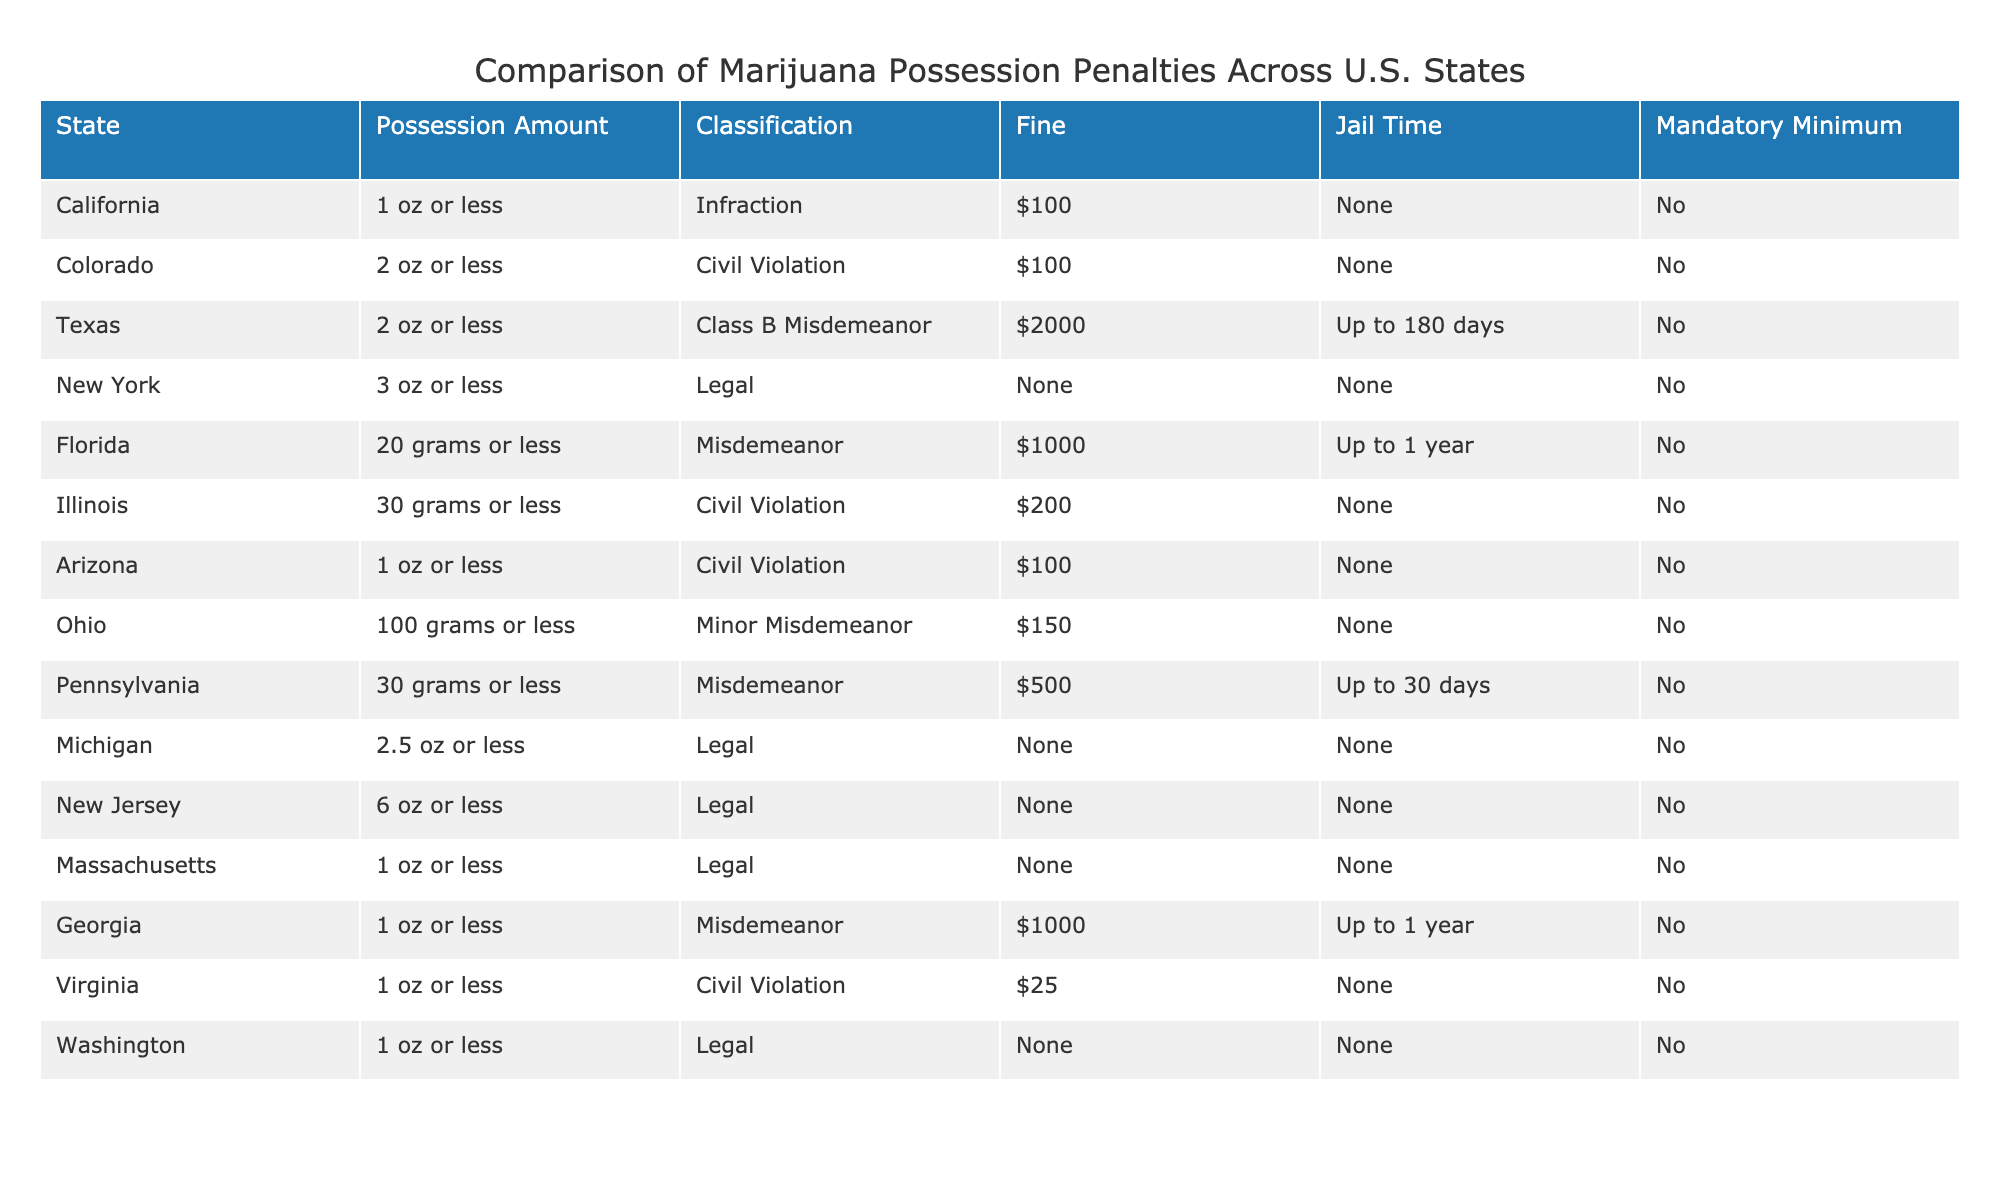What is the possession amount limit in California? According to the table, California allows possession of up to 1 ounce of marijuana or less.
Answer: 1 oz or less Which state has the highest fine for marijuana possession? The table shows that Texas imposes a fine of $2000 for possession of 2 ounces or less, which is the highest fine listed.
Answer: Texas Is marijuana possession legalized in New York? The table indicates that marijuana possession is legal in New York for up to 3 ounces.
Answer: Yes How many states classify marijuana possession as a civil violation? From the table, California, Colorado, Illinois, Arizona, and Virginia classify marijuana possession as a civil violation, totaling 5 states.
Answer: 5 states What is the jail time for possessing 30 grams of marijuana in Pennsylvania? The table states that possession of 30 grams in Pennsylvania is classified as a misdemeanor with a jail time of up to 30 days.
Answer: Up to 30 days Are there any states with a mandatory minimum sentence for marijuana possession? The table shows that no states have a mandatory minimum sentence listed for marijuana possession.
Answer: No Which two states have the same possession amount limit but differ in classification and fines? Florida (20 grams or less, Misdemeanor, $1000) and Ohio (100 grams or less, Minor Misdemeanor, $150) both have different classifications and fines, despite their specified amounts.
Answer: Florida and Ohio If a person is caught with 2 ounces in Colorado, what would be the potential penalties? In Colorado, possessing 2 ounces or less is classified as a civil violation with a fine of $100 and no jail time.
Answer: $100 fine, no jail time What is the average fine for states where marijuana possession is legal? The legal states listed are New York, Michigan, New Jersey, Massachusetts, and Washington. The fines for these states are all $0. Therefore, the average fine is 0/5 = 0.
Answer: $0 Which state has the lowest fine for marijuana possession? The table indicates that Virginia has the lowest fine of $25 for possession of 1 ounce or less.
Answer: $25 